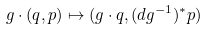Convert formula to latex. <formula><loc_0><loc_0><loc_500><loc_500>g \cdot ( q , p ) \mapsto ( g \cdot q , ( d g ^ { - 1 } ) ^ { * } p )</formula> 